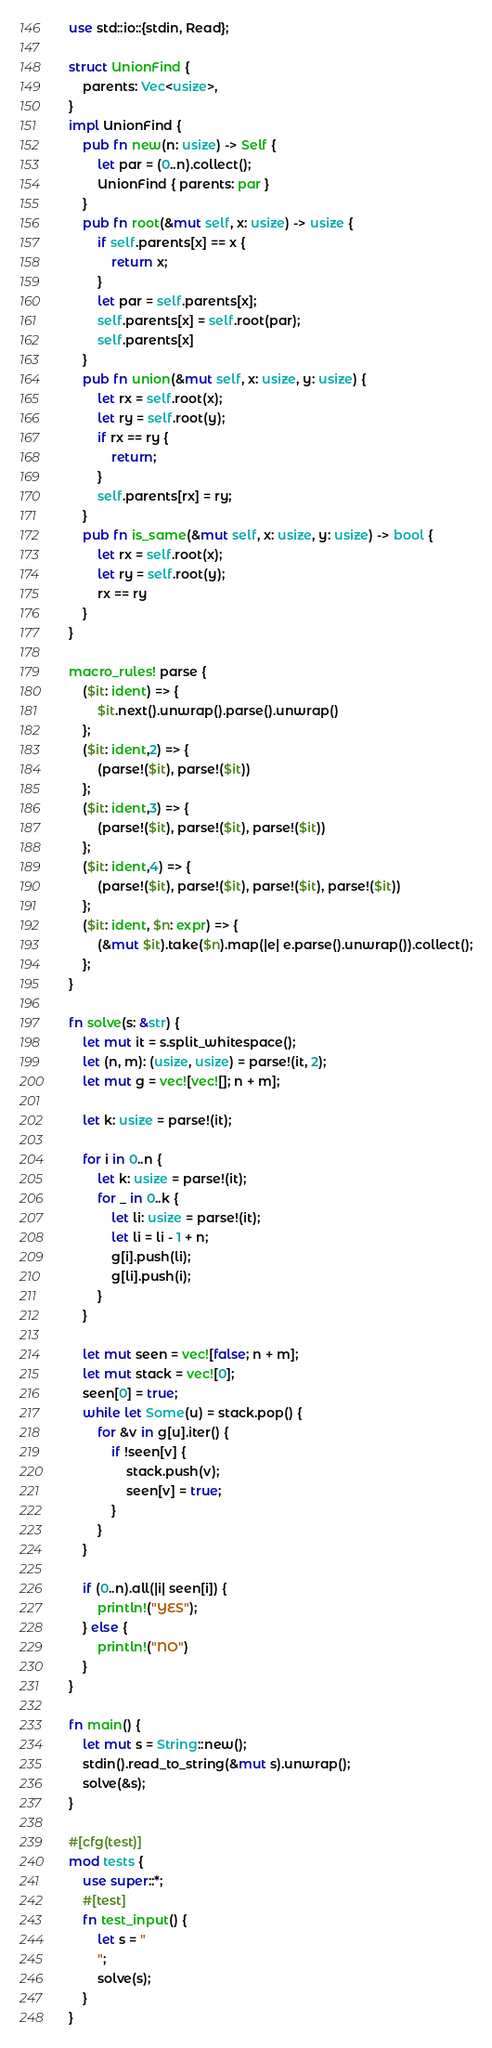Convert code to text. <code><loc_0><loc_0><loc_500><loc_500><_Rust_>use std::io::{stdin, Read};

struct UnionFind {
    parents: Vec<usize>,
}
impl UnionFind {
    pub fn new(n: usize) -> Self {
        let par = (0..n).collect();
        UnionFind { parents: par }
    }
    pub fn root(&mut self, x: usize) -> usize {
        if self.parents[x] == x {
            return x;
        }
        let par = self.parents[x];
        self.parents[x] = self.root(par);
        self.parents[x]
    }
    pub fn union(&mut self, x: usize, y: usize) {
        let rx = self.root(x);
        let ry = self.root(y);
        if rx == ry {
            return;
        }
        self.parents[rx] = ry;
    }
    pub fn is_same(&mut self, x: usize, y: usize) -> bool {
        let rx = self.root(x);
        let ry = self.root(y);
        rx == ry
    }
}

macro_rules! parse {
    ($it: ident) => {
        $it.next().unwrap().parse().unwrap()
    };
    ($it: ident,2) => {
        (parse!($it), parse!($it))
    };
    ($it: ident,3) => {
        (parse!($it), parse!($it), parse!($it))
    };
    ($it: ident,4) => {
        (parse!($it), parse!($it), parse!($it), parse!($it))
    };
    ($it: ident, $n: expr) => {
        (&mut $it).take($n).map(|e| e.parse().unwrap()).collect();
    };
}

fn solve(s: &str) {
    let mut it = s.split_whitespace();
    let (n, m): (usize, usize) = parse!(it, 2);
    let mut g = vec![vec![]; n + m];

    let k: usize = parse!(it);

    for i in 0..n {
        let k: usize = parse!(it);
        for _ in 0..k {
            let li: usize = parse!(it);
            let li = li - 1 + n;
            g[i].push(li);
            g[li].push(i);
        }
    }

    let mut seen = vec![false; n + m];
    let mut stack = vec![0];
    seen[0] = true;
    while let Some(u) = stack.pop() {
        for &v in g[u].iter() {
            if !seen[v] {
                stack.push(v);
                seen[v] = true;
            }
        }
    }

    if (0..n).all(|i| seen[i]) {
        println!("YES");
    } else {
        println!("NO")
    }
}

fn main() {
    let mut s = String::new();
    stdin().read_to_string(&mut s).unwrap();
    solve(&s);
}

#[cfg(test)]
mod tests {
    use super::*;
    #[test]
    fn test_input() {
        let s = "
        ";
        solve(s);
    }
}
</code> 